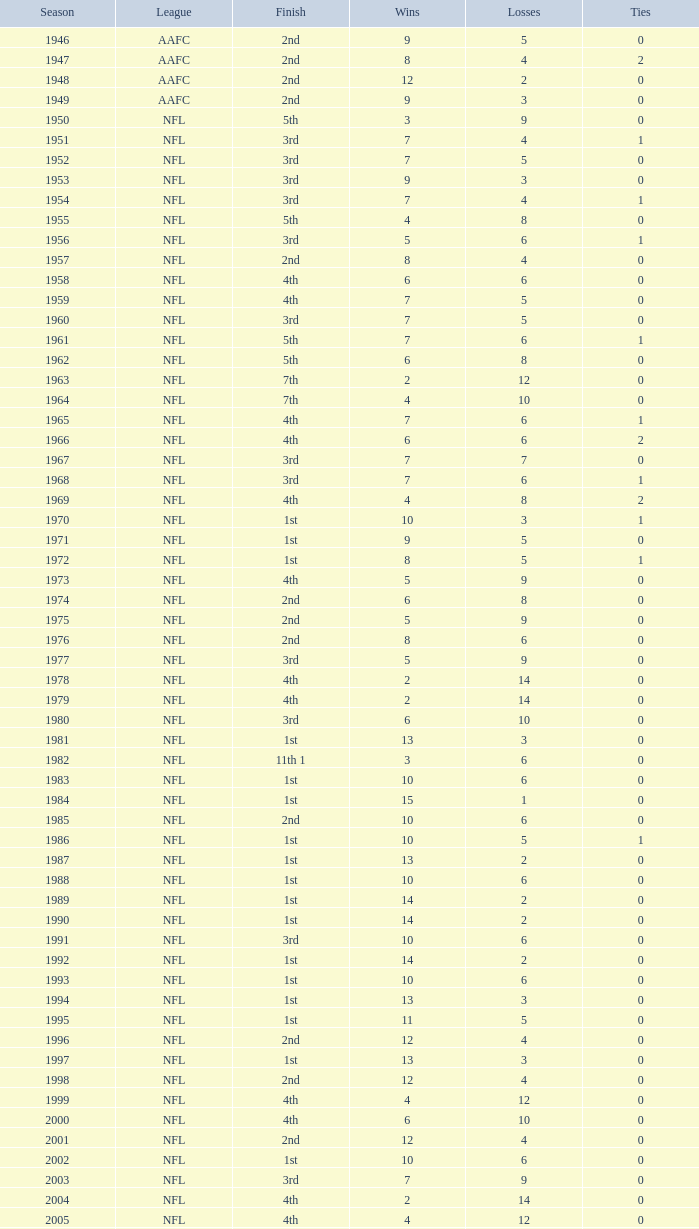What league had a finish of 2nd and 3 losses? AAFC. 